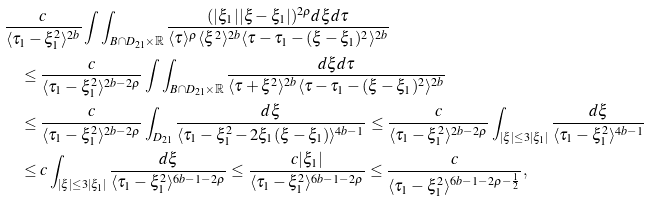Convert formula to latex. <formula><loc_0><loc_0><loc_500><loc_500>& \frac { c } { \langle \tau _ { 1 } - \xi _ { 1 } ^ { 2 } \rangle ^ { 2 b } } \int \int _ { B \cap D _ { 2 1 } \times \mathbb { R } } \frac { ( | \xi _ { 1 } | | \xi - \xi _ { 1 } | ) ^ { 2 \rho } d \xi d \tau } { \langle \tau \rangle ^ { \rho } \langle \xi ^ { 2 } \rangle ^ { 2 b } \langle \tau - \tau _ { 1 } - ( \xi - \xi _ { 1 } ) ^ { 2 } \rangle ^ { 2 b } } \\ & \quad \leq \frac { c } { \langle \tau _ { 1 } - \xi _ { 1 } ^ { 2 } \rangle ^ { 2 b - 2 \rho } } \int \int _ { B \cap D _ { 2 1 } \times \mathbb { R } } \frac { d \xi d \tau } { \langle \tau + \xi ^ { 2 } \rangle ^ { 2 b } \langle \tau - \tau _ { 1 } - ( \xi - \xi _ { 1 } ) ^ { 2 } \rangle ^ { 2 b } } \\ & \quad \leq \frac { c } { \langle \tau _ { 1 } - \xi _ { 1 } ^ { 2 } \rangle ^ { 2 b - 2 \rho } } \int _ { D _ { 2 1 } } \frac { d \xi } { \langle \tau _ { 1 } - \xi _ { 1 } ^ { 2 } - 2 \xi _ { 1 } ( \xi - \xi _ { 1 } ) \rangle ^ { 4 b - 1 } } \leq \frac { c } { \langle \tau _ { 1 } - \xi _ { 1 } ^ { 2 } \rangle ^ { 2 b - 2 \rho } } \int _ { | \xi | \leq 3 | \xi _ { 1 } | } \frac { d \xi } { \langle \tau _ { 1 } - \xi _ { 1 } ^ { 2 } \rangle ^ { 4 b - 1 } } \\ & \quad \leq c \int _ { | \xi | \leq 3 | \xi _ { 1 } | } \frac { d \xi } { \langle \tau _ { 1 } - \xi _ { 1 } ^ { 2 } \rangle ^ { 6 b - 1 - 2 \rho } } \leq \frac { c | \xi _ { 1 } | } { \langle \tau _ { 1 } - \xi _ { 1 } ^ { 2 } \rangle ^ { 6 b - 1 - 2 \rho } } \leq \frac { c } { \langle \tau _ { 1 } - \xi _ { 1 } ^ { 2 } \rangle ^ { 6 b - 1 - 2 \rho - \frac { 1 } { 2 } } } ,</formula> 